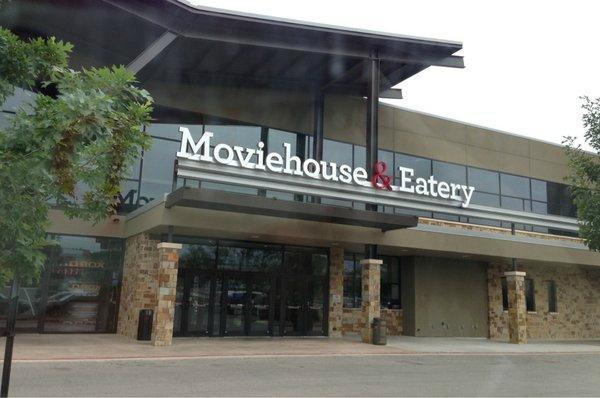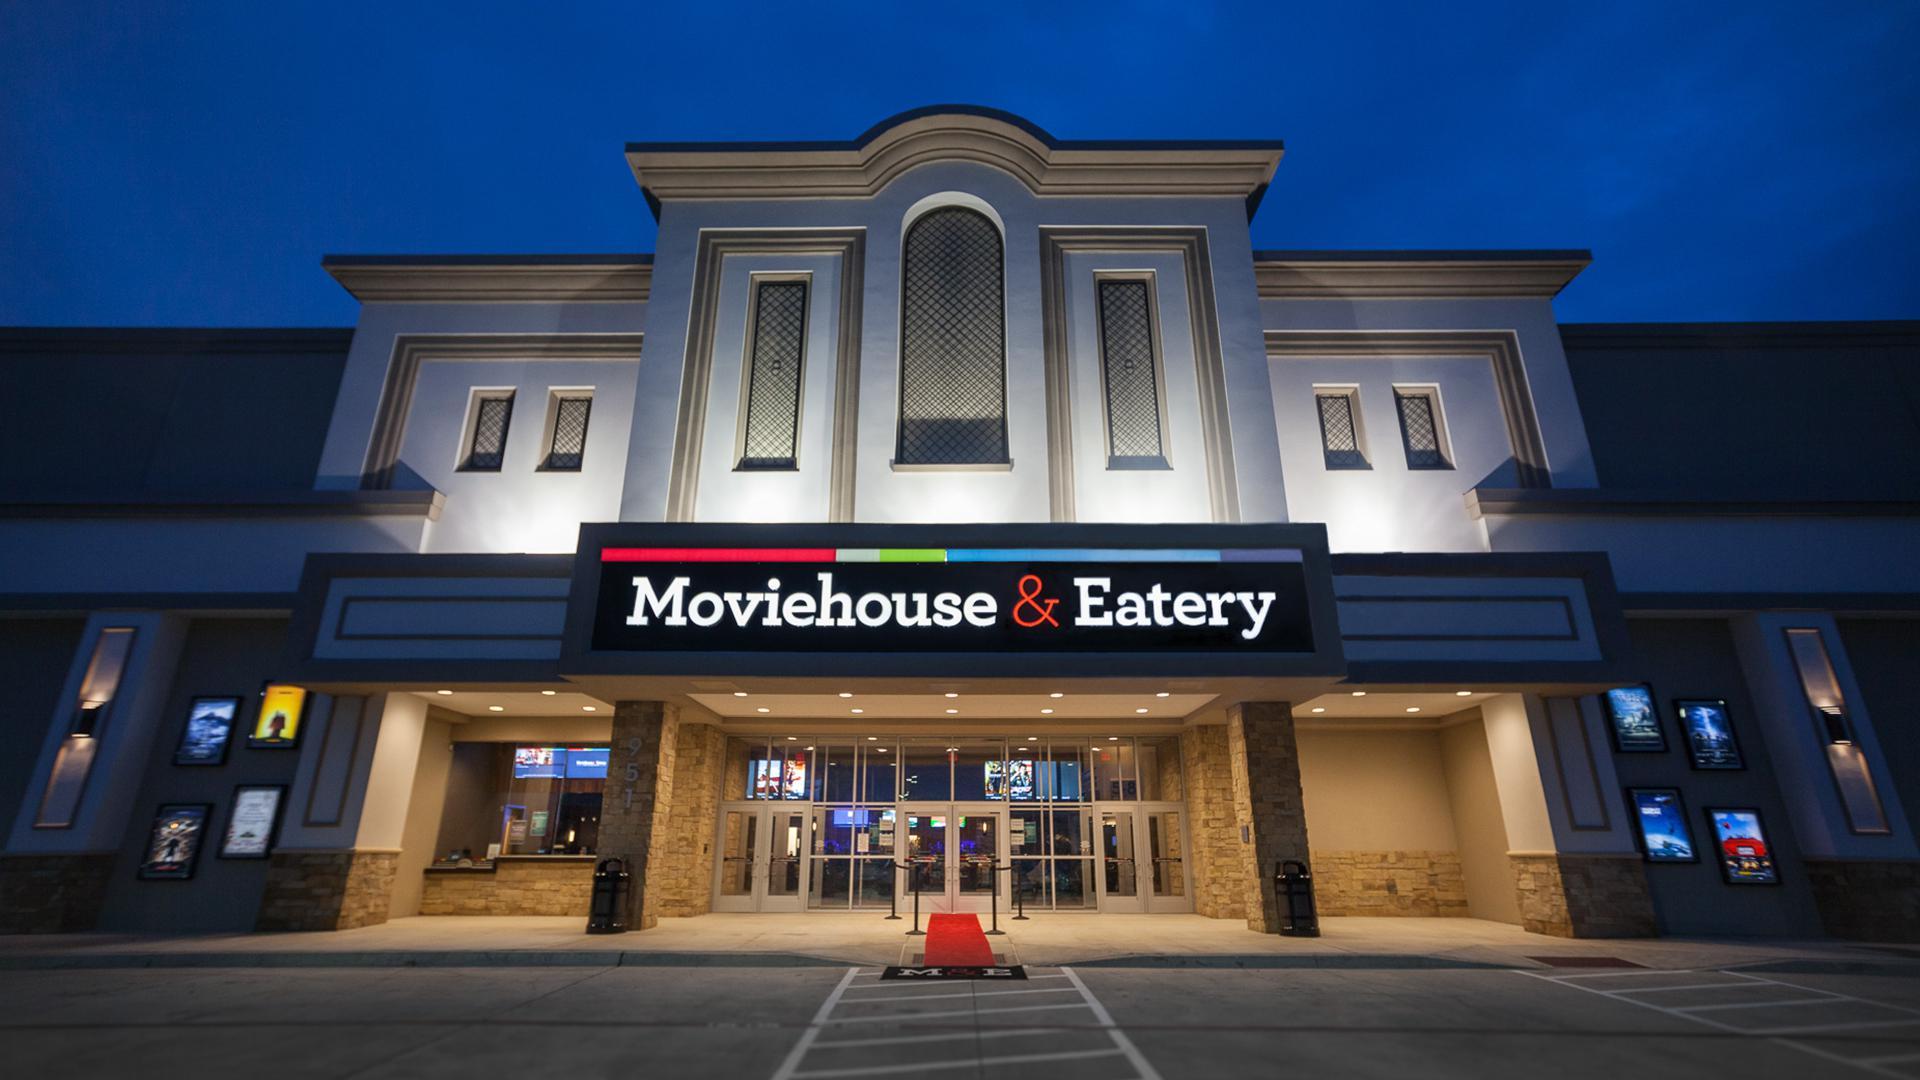The first image is the image on the left, the second image is the image on the right. Assess this claim about the two images: "The right image shows an interior with backless stools leading to white chair-type stools at a bar with glowing yellow underlighting.". Correct or not? Answer yes or no. No. The first image is the image on the left, the second image is the image on the right. Given the left and right images, does the statement "Signage hangs above the entrance of the place in the image on the right." hold true? Answer yes or no. Yes. 